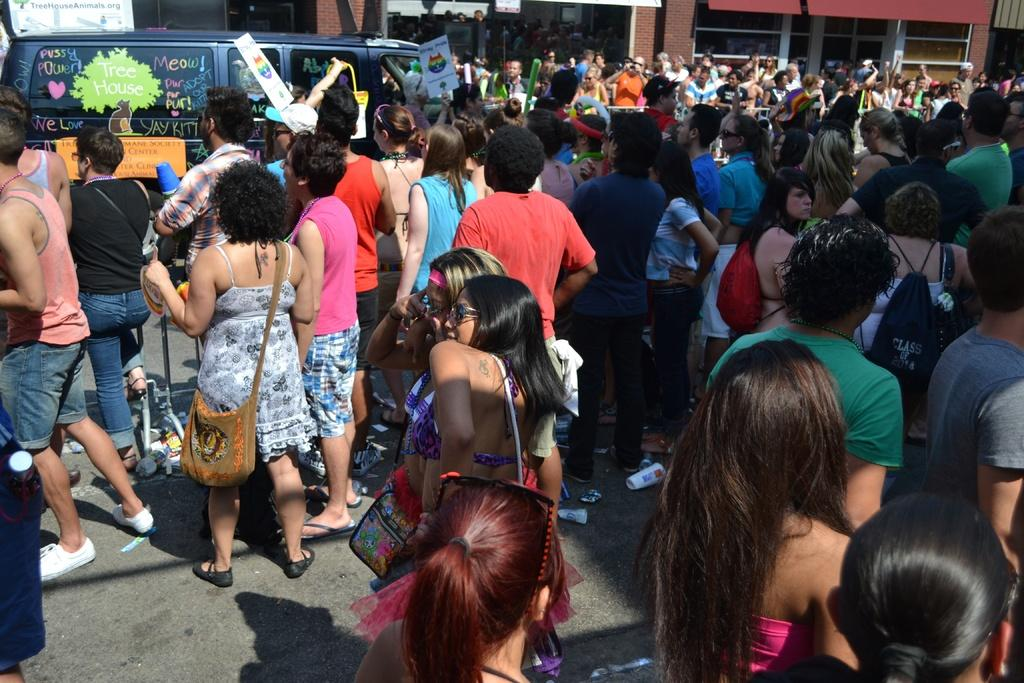What is the main subject of the image? The main subject of the image is a crowd of people. What else can be seen in the background of the image? There is a building visible in the image? Are there any other objects or vehicles present in the image? Yes, there is a vehicle in the image. What type of silk is being sold in the shop in the image? There is no shop or silk present in the image. Who is the expert in the image providing advice to the crowd? There is no expert or advice-giving situation depicted in the image. 